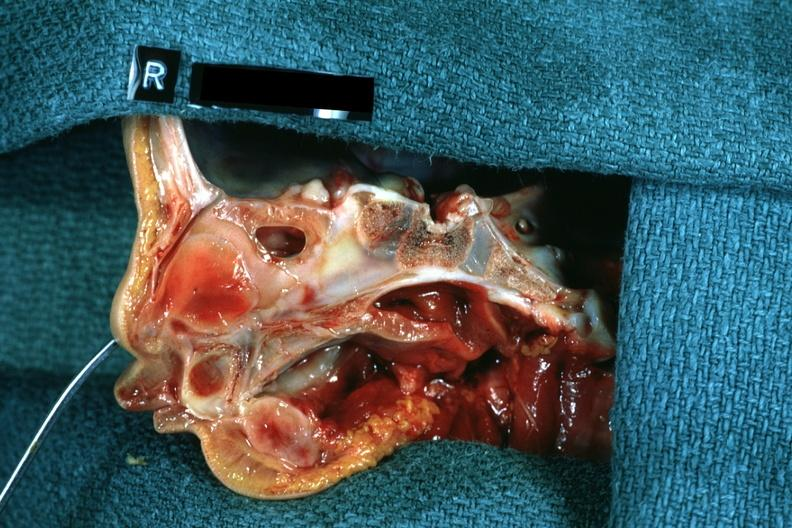s choanal atresia present?
Answer the question using a single word or phrase. Yes 